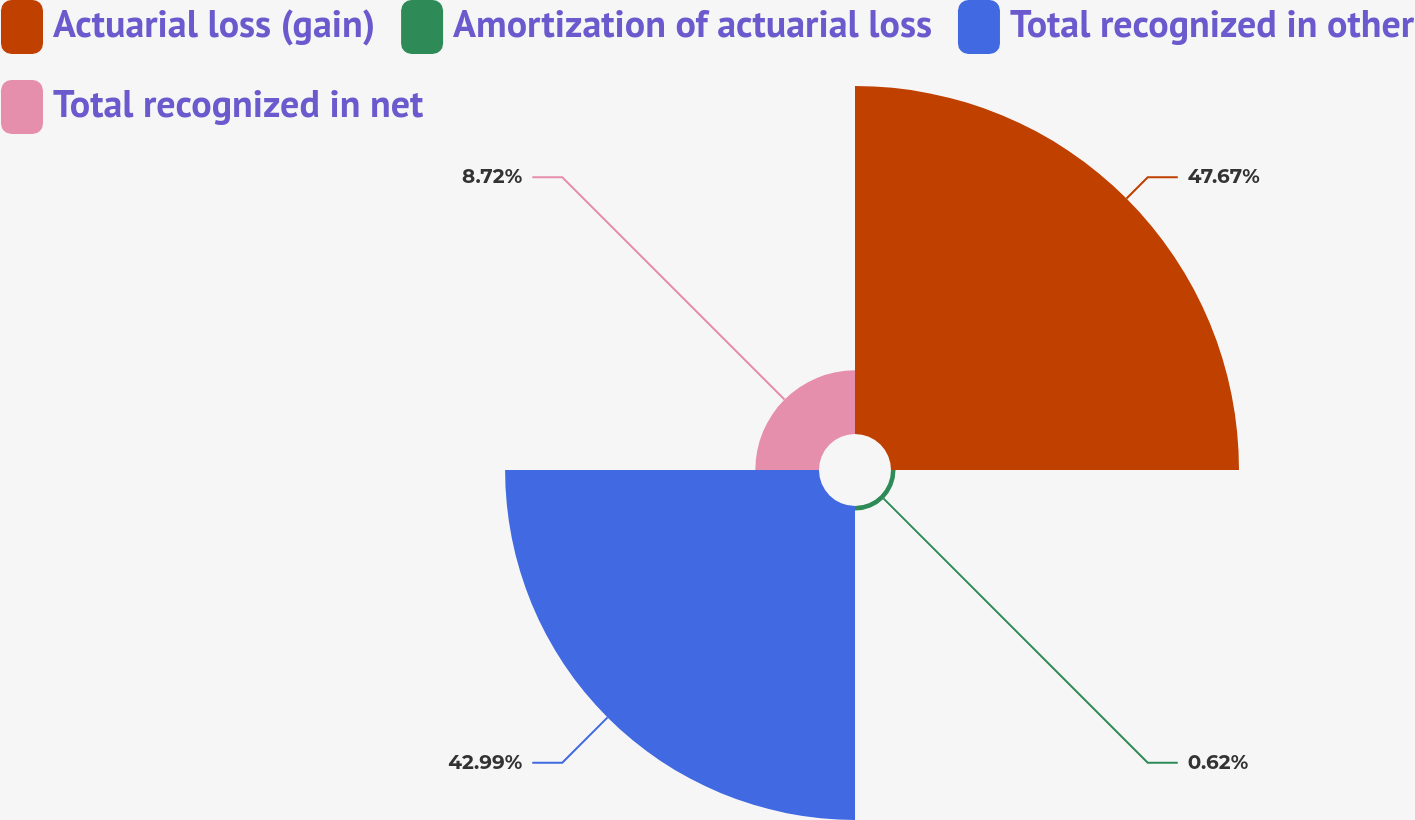<chart> <loc_0><loc_0><loc_500><loc_500><pie_chart><fcel>Actuarial loss (gain)<fcel>Amortization of actuarial loss<fcel>Total recognized in other<fcel>Total recognized in net<nl><fcel>47.66%<fcel>0.62%<fcel>42.99%<fcel>8.72%<nl></chart> 